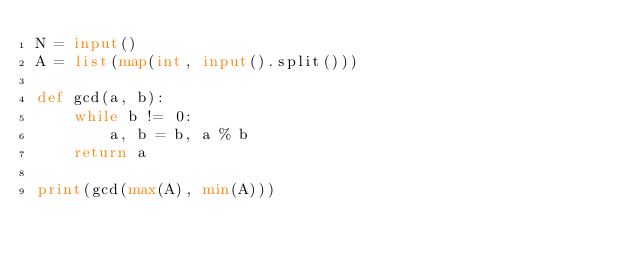Convert code to text. <code><loc_0><loc_0><loc_500><loc_500><_Python_>N = input()
A = list(map(int, input().split()))

def gcd(a, b):
    while b != 0:
        a, b = b, a % b
    return a

print(gcd(max(A), min(A)))</code> 